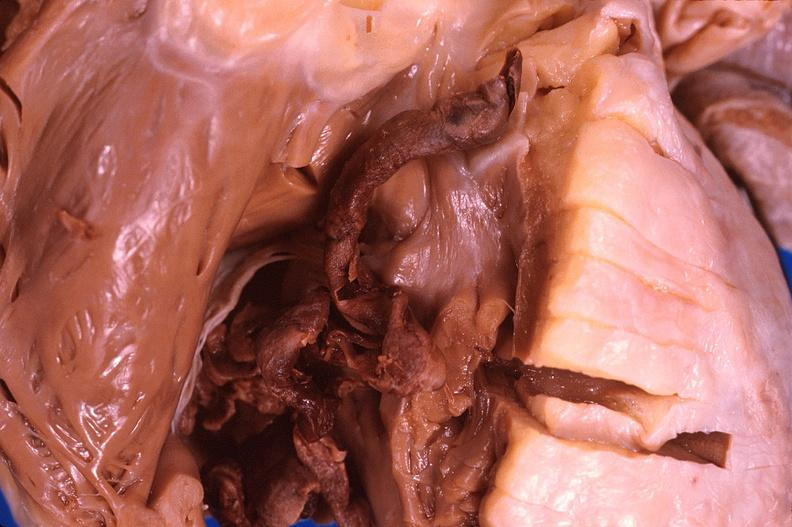what is present?
Answer the question using a single word or phrase. Heart 